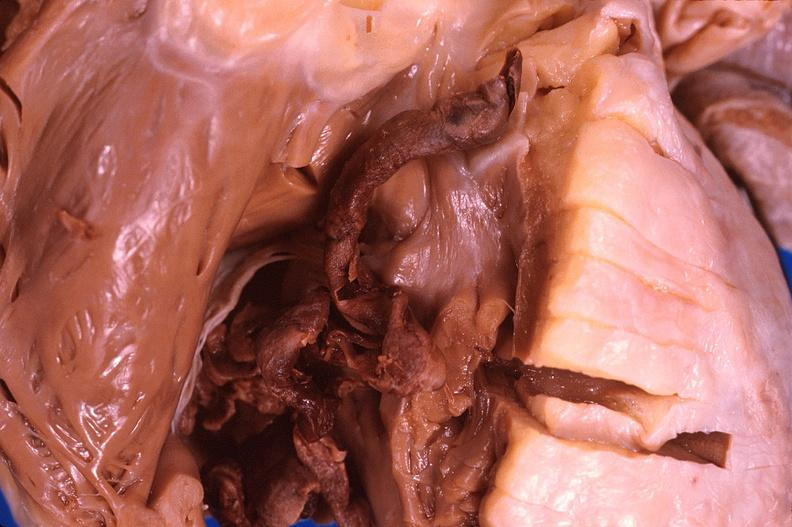what is present?
Answer the question using a single word or phrase. Heart 